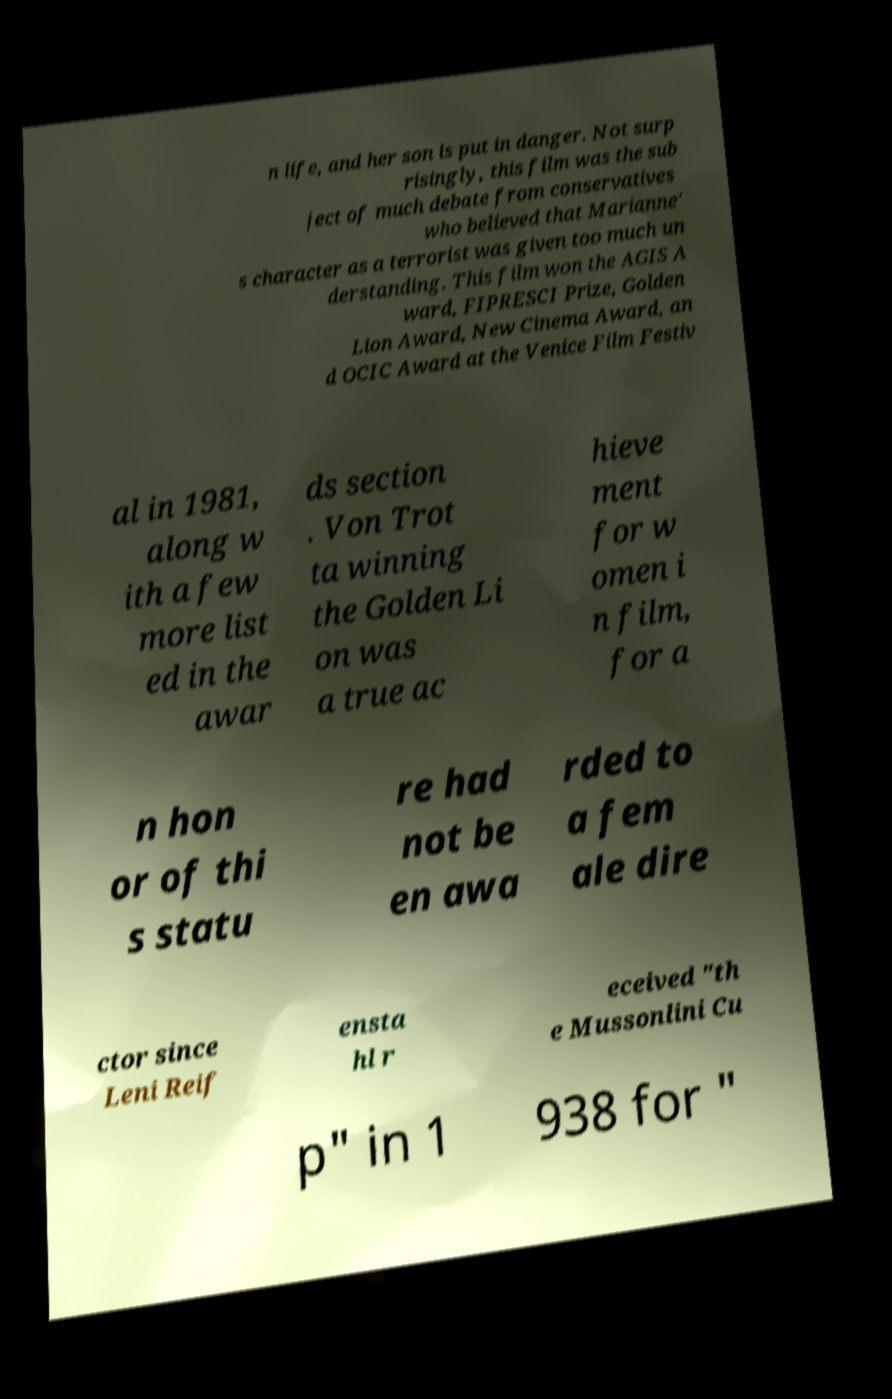Please identify and transcribe the text found in this image. n life, and her son is put in danger. Not surp risingly, this film was the sub ject of much debate from conservatives who believed that Marianne' s character as a terrorist was given too much un derstanding. This film won the AGIS A ward, FIPRESCI Prize, Golden Lion Award, New Cinema Award, an d OCIC Award at the Venice Film Festiv al in 1981, along w ith a few more list ed in the awar ds section . Von Trot ta winning the Golden Li on was a true ac hieve ment for w omen i n film, for a n hon or of thi s statu re had not be en awa rded to a fem ale dire ctor since Leni Reif ensta hl r eceived "th e Mussonlini Cu p" in 1 938 for " 